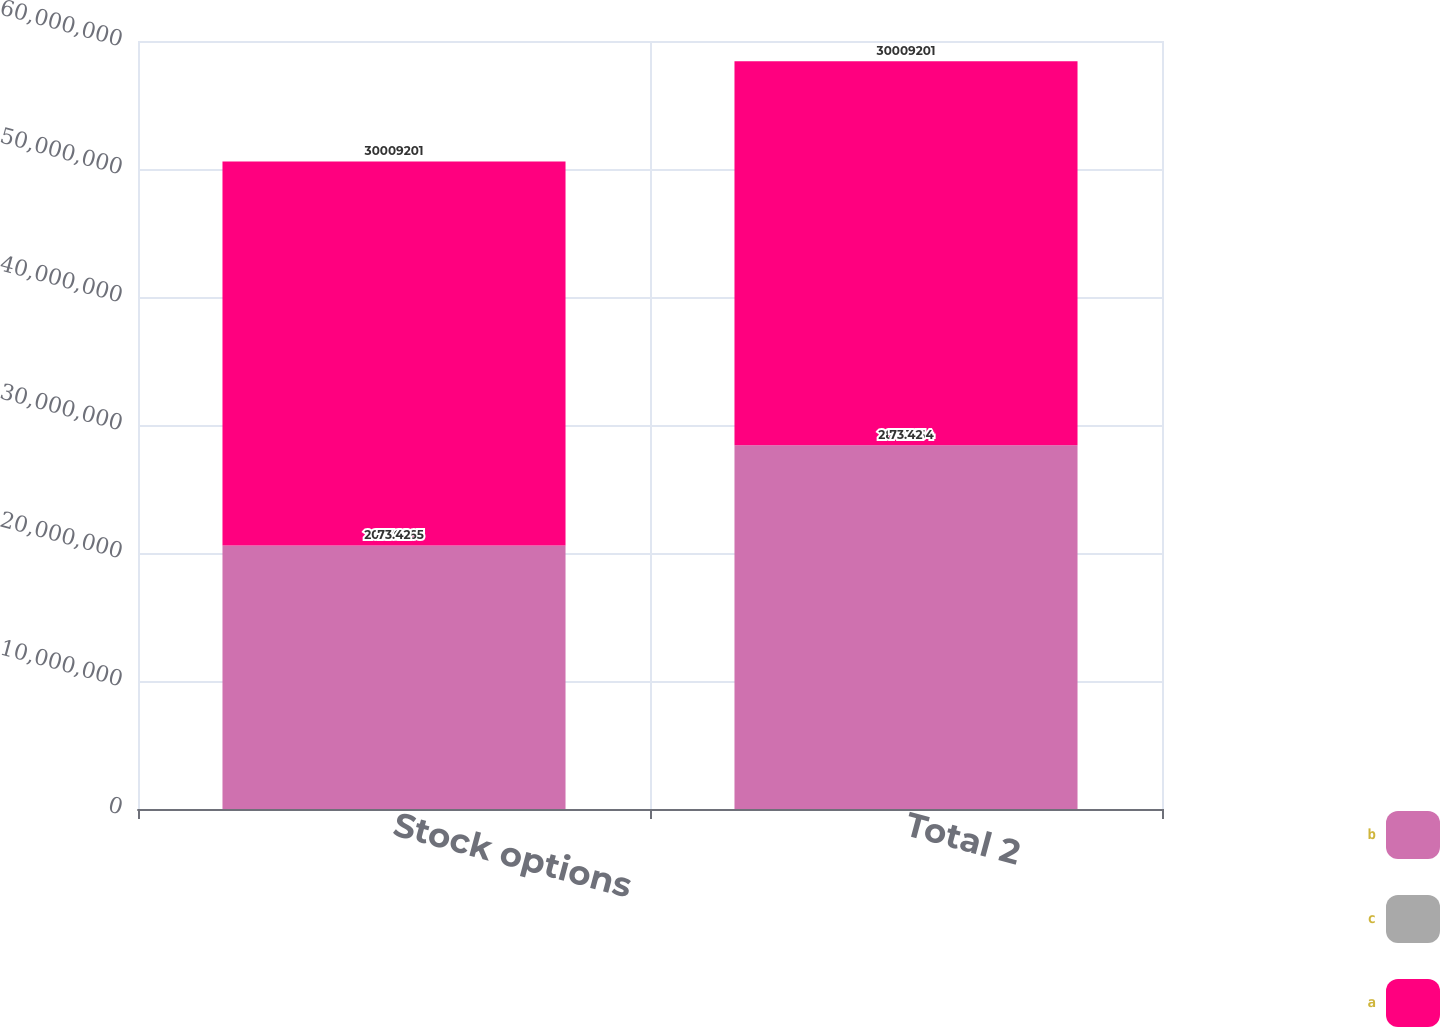Convert chart. <chart><loc_0><loc_0><loc_500><loc_500><stacked_bar_chart><ecel><fcel>Stock options<fcel>Total 2<nl><fcel>b<fcel>2.05769e+07<fcel>2.84116e+07<nl><fcel>c<fcel>73.42<fcel>73.42<nl><fcel>a<fcel>3.00092e+07<fcel>3.00092e+07<nl></chart> 